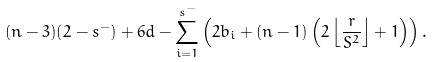<formula> <loc_0><loc_0><loc_500><loc_500>( n - 3 ) ( 2 - s ^ { - } ) + 6 d - \sum _ { i = 1 } ^ { s ^ { - } } \left ( 2 b _ { i } + ( n - 1 ) \left ( 2 \left \lfloor \frac { r } { S ^ { 2 } } \right \rfloor + 1 \right ) \right ) .</formula> 